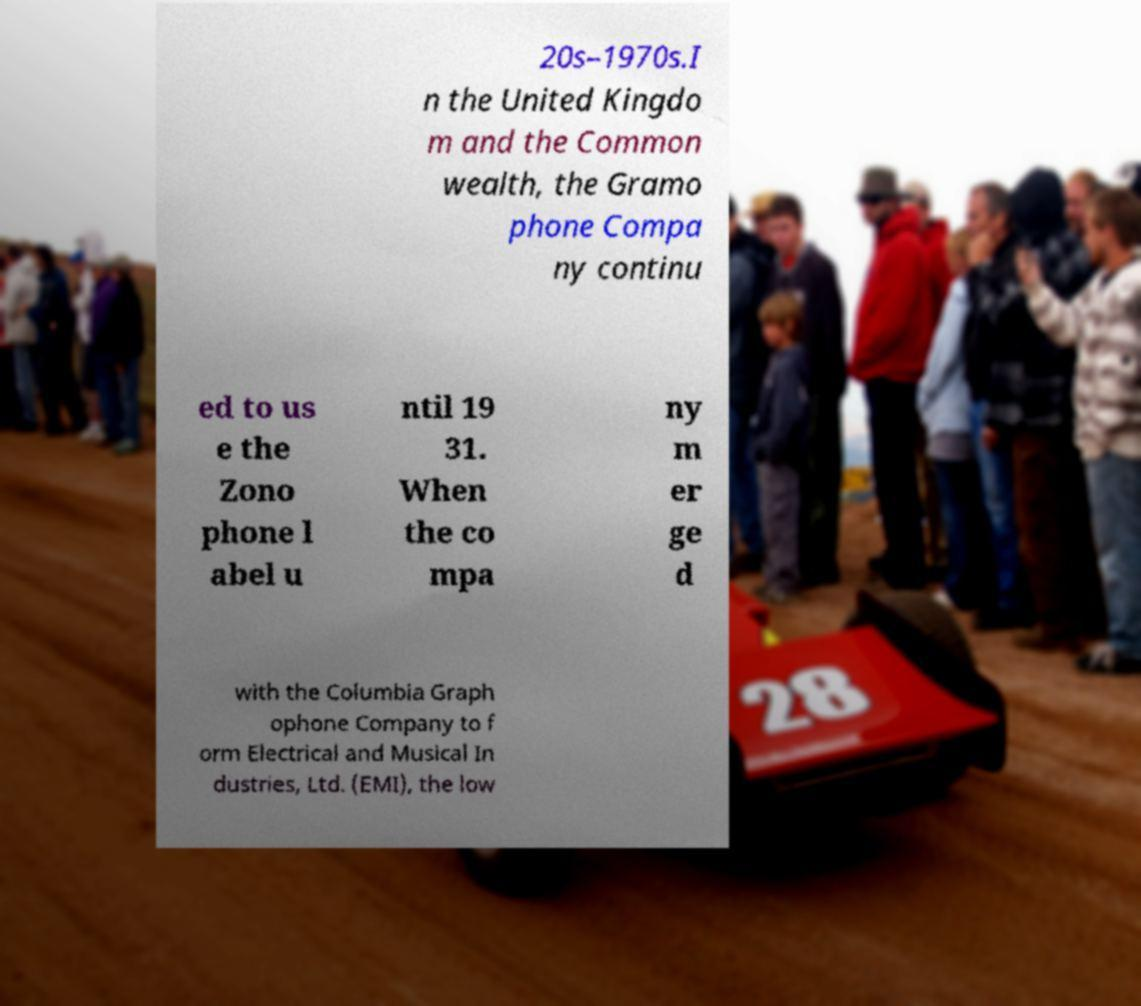Please read and relay the text visible in this image. What does it say? 20s–1970s.I n the United Kingdo m and the Common wealth, the Gramo phone Compa ny continu ed to us e the Zono phone l abel u ntil 19 31. When the co mpa ny m er ge d with the Columbia Graph ophone Company to f orm Electrical and Musical In dustries, Ltd. (EMI), the low 